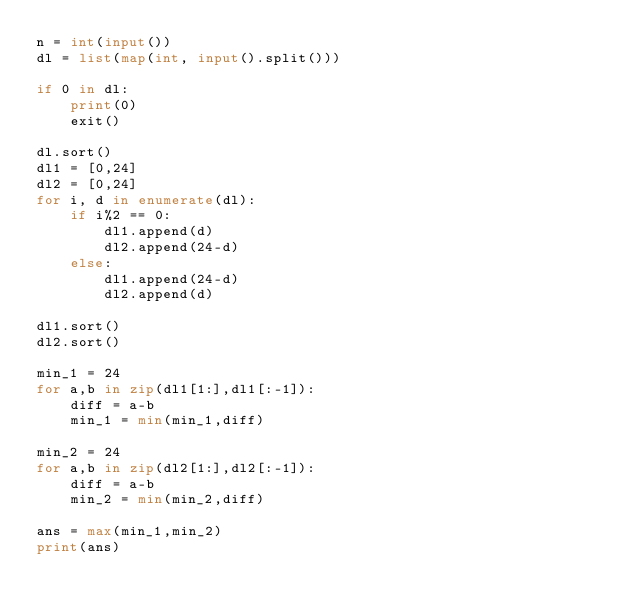<code> <loc_0><loc_0><loc_500><loc_500><_Python_>n = int(input())
dl = list(map(int, input().split()))

if 0 in dl:
    print(0)
    exit()

dl.sort()
dl1 = [0,24]
dl2 = [0,24]
for i, d in enumerate(dl):
    if i%2 == 0:
        dl1.append(d)
        dl2.append(24-d)
    else:
        dl1.append(24-d)
        dl2.append(d)

dl1.sort()
dl2.sort()

min_1 = 24
for a,b in zip(dl1[1:],dl1[:-1]):
    diff = a-b
    min_1 = min(min_1,diff)

min_2 = 24
for a,b in zip(dl2[1:],dl2[:-1]):
    diff = a-b
    min_2 = min(min_2,diff)

ans = max(min_1,min_2)
print(ans)
</code> 